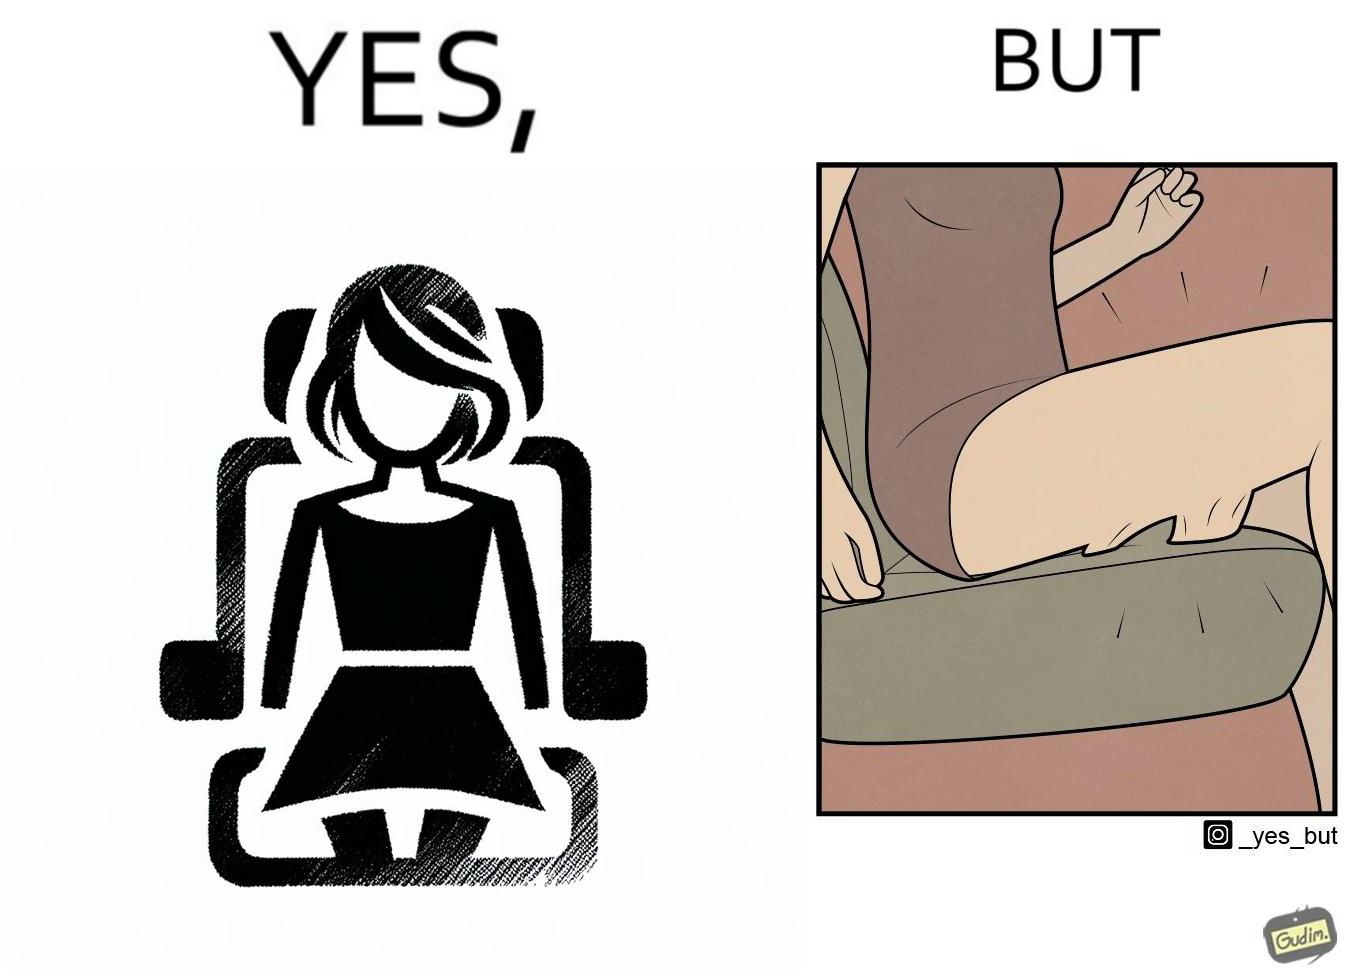Describe what you see in this image. The image is ironic, because the woman is wearing a short dress to look stylish but she had to face inconvenience while travelling in car due to her short dress only. 